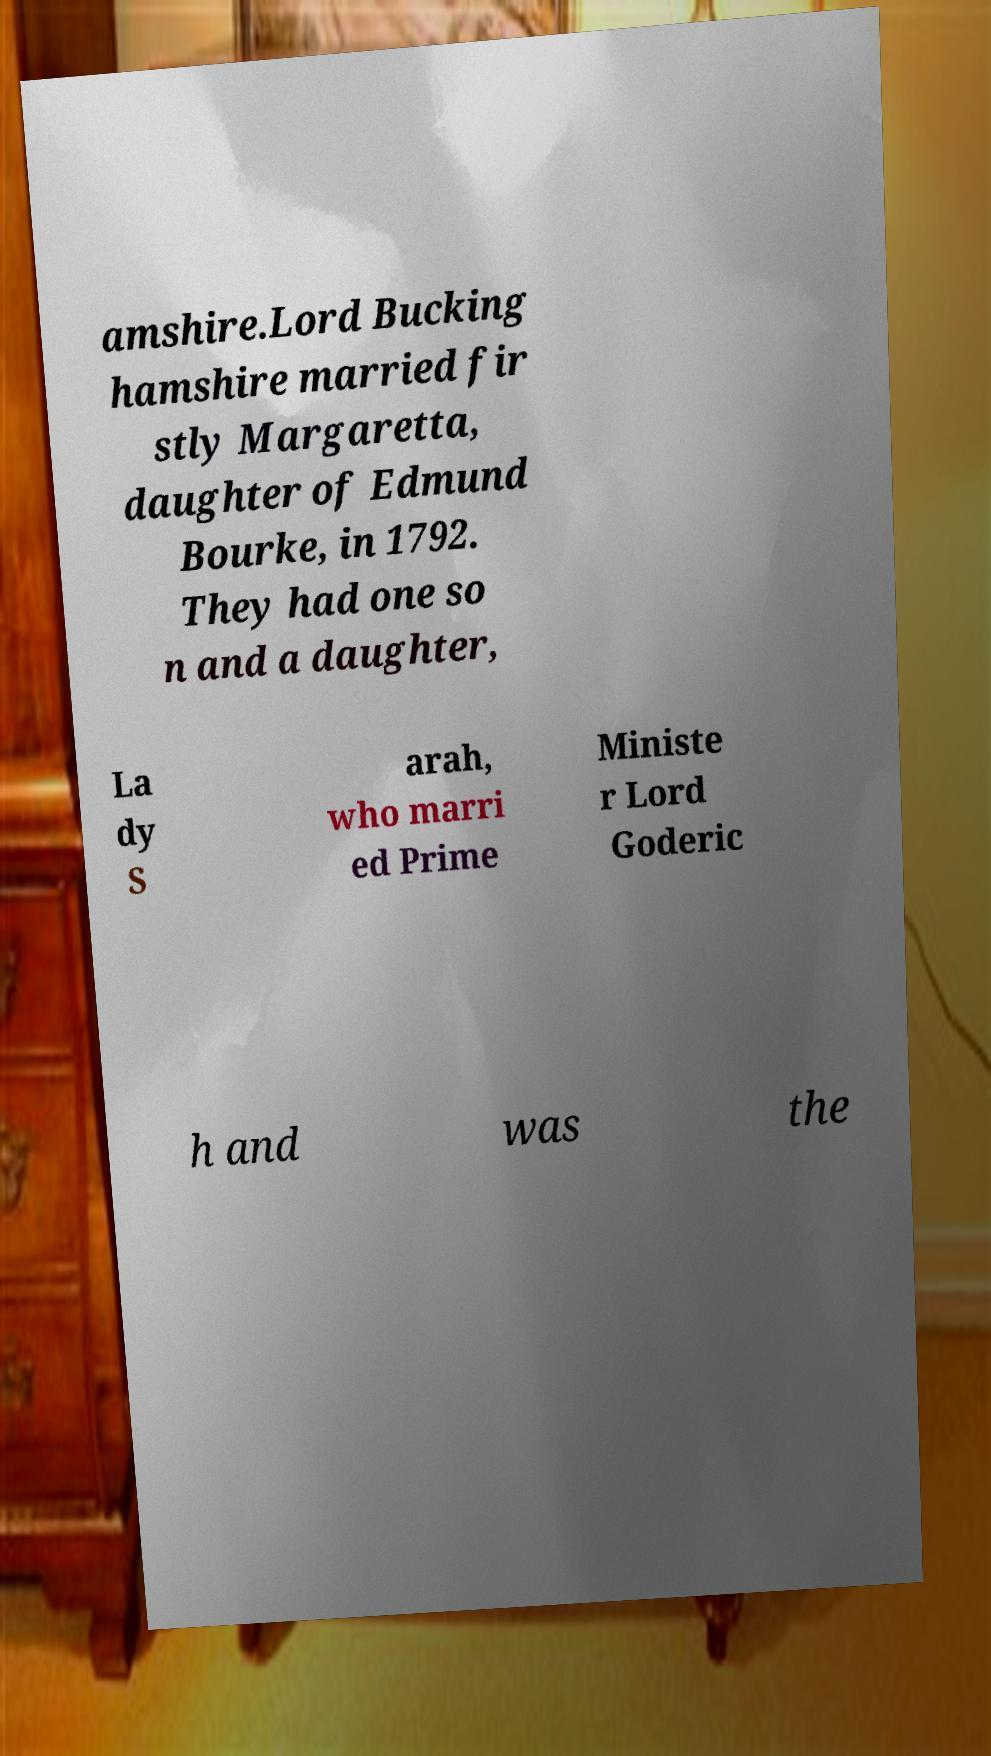Can you read and provide the text displayed in the image?This photo seems to have some interesting text. Can you extract and type it out for me? amshire.Lord Bucking hamshire married fir stly Margaretta, daughter of Edmund Bourke, in 1792. They had one so n and a daughter, La dy S arah, who marri ed Prime Ministe r Lord Goderic h and was the 